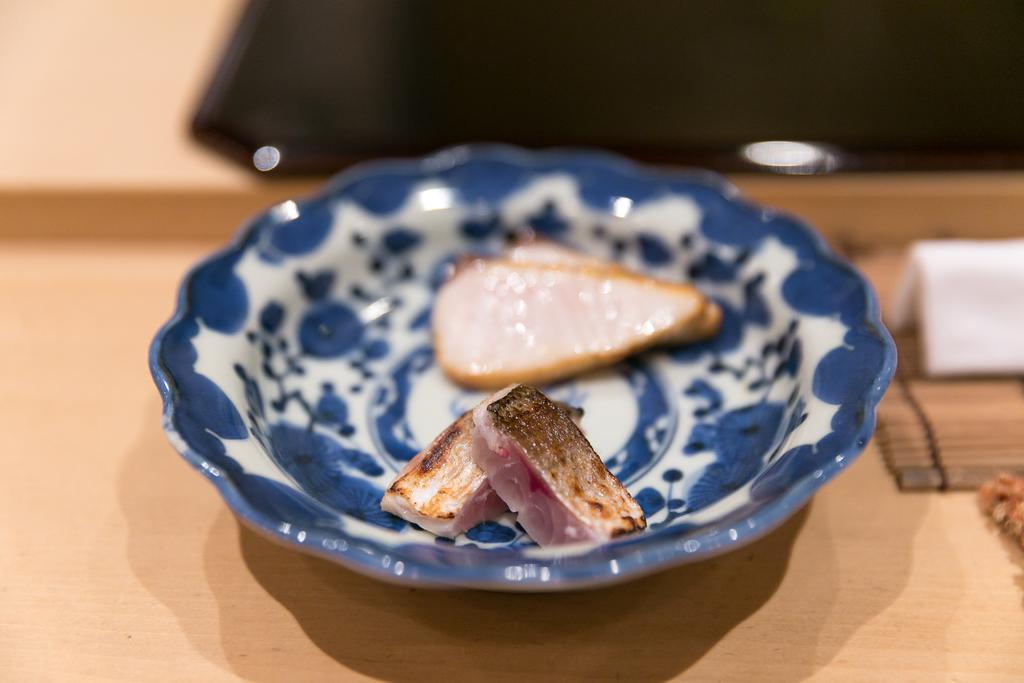What animals are present in the image? There are two fish in the image. Where are the fish located? The fish are in a bowl. Can you describe the background of the bowl? The background of the bowl is blurred. What type of pies can be seen floating in the water with the fish? There are no pies present in the image; it features two fish in a bowl with a blurred background. 